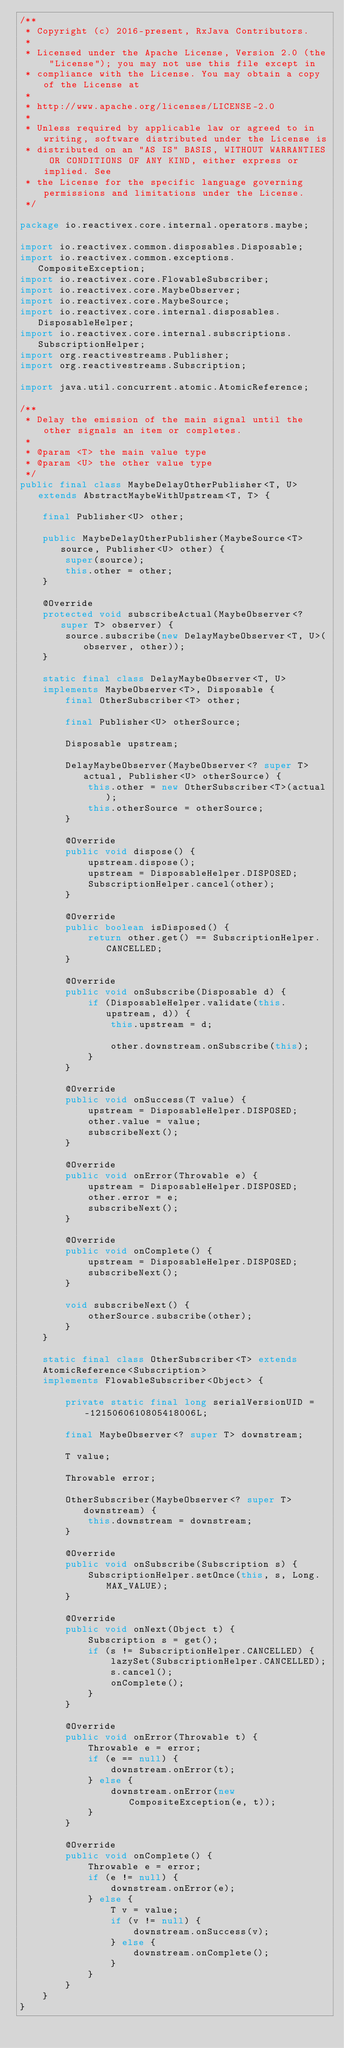Convert code to text. <code><loc_0><loc_0><loc_500><loc_500><_Java_>/**
 * Copyright (c) 2016-present, RxJava Contributors.
 *
 * Licensed under the Apache License, Version 2.0 (the "License"); you may not use this file except in
 * compliance with the License. You may obtain a copy of the License at
 *
 * http://www.apache.org/licenses/LICENSE-2.0
 *
 * Unless required by applicable law or agreed to in writing, software distributed under the License is
 * distributed on an "AS IS" BASIS, WITHOUT WARRANTIES OR CONDITIONS OF ANY KIND, either express or implied. See
 * the License for the specific language governing permissions and limitations under the License.
 */

package io.reactivex.core.internal.operators.maybe;

import io.reactivex.common.disposables.Disposable;
import io.reactivex.common.exceptions.CompositeException;
import io.reactivex.core.FlowableSubscriber;
import io.reactivex.core.MaybeObserver;
import io.reactivex.core.MaybeSource;
import io.reactivex.core.internal.disposables.DisposableHelper;
import io.reactivex.core.internal.subscriptions.SubscriptionHelper;
import org.reactivestreams.Publisher;
import org.reactivestreams.Subscription;

import java.util.concurrent.atomic.AtomicReference;

/**
 * Delay the emission of the main signal until the other signals an item or completes.
 * 
 * @param <T> the main value type
 * @param <U> the other value type
 */
public final class MaybeDelayOtherPublisher<T, U> extends AbstractMaybeWithUpstream<T, T> {

    final Publisher<U> other;

    public MaybeDelayOtherPublisher(MaybeSource<T> source, Publisher<U> other) {
        super(source);
        this.other = other;
    }

    @Override
    protected void subscribeActual(MaybeObserver<? super T> observer) {
        source.subscribe(new DelayMaybeObserver<T, U>(observer, other));
    }

    static final class DelayMaybeObserver<T, U>
    implements MaybeObserver<T>, Disposable {
        final OtherSubscriber<T> other;

        final Publisher<U> otherSource;

        Disposable upstream;

        DelayMaybeObserver(MaybeObserver<? super T> actual, Publisher<U> otherSource) {
            this.other = new OtherSubscriber<T>(actual);
            this.otherSource = otherSource;
        }

        @Override
        public void dispose() {
            upstream.dispose();
            upstream = DisposableHelper.DISPOSED;
            SubscriptionHelper.cancel(other);
        }

        @Override
        public boolean isDisposed() {
            return other.get() == SubscriptionHelper.CANCELLED;
        }

        @Override
        public void onSubscribe(Disposable d) {
            if (DisposableHelper.validate(this.upstream, d)) {
                this.upstream = d;

                other.downstream.onSubscribe(this);
            }
        }

        @Override
        public void onSuccess(T value) {
            upstream = DisposableHelper.DISPOSED;
            other.value = value;
            subscribeNext();
        }

        @Override
        public void onError(Throwable e) {
            upstream = DisposableHelper.DISPOSED;
            other.error = e;
            subscribeNext();
        }

        @Override
        public void onComplete() {
            upstream = DisposableHelper.DISPOSED;
            subscribeNext();
        }

        void subscribeNext() {
            otherSource.subscribe(other);
        }
    }

    static final class OtherSubscriber<T> extends
    AtomicReference<Subscription>
    implements FlowableSubscriber<Object> {

        private static final long serialVersionUID = -1215060610805418006L;

        final MaybeObserver<? super T> downstream;

        T value;

        Throwable error;

        OtherSubscriber(MaybeObserver<? super T> downstream) {
            this.downstream = downstream;
        }

        @Override
        public void onSubscribe(Subscription s) {
            SubscriptionHelper.setOnce(this, s, Long.MAX_VALUE);
        }

        @Override
        public void onNext(Object t) {
            Subscription s = get();
            if (s != SubscriptionHelper.CANCELLED) {
                lazySet(SubscriptionHelper.CANCELLED);
                s.cancel();
                onComplete();
            }
        }

        @Override
        public void onError(Throwable t) {
            Throwable e = error;
            if (e == null) {
                downstream.onError(t);
            } else {
                downstream.onError(new CompositeException(e, t));
            }
        }

        @Override
        public void onComplete() {
            Throwable e = error;
            if (e != null) {
                downstream.onError(e);
            } else {
                T v = value;
                if (v != null) {
                    downstream.onSuccess(v);
                } else {
                    downstream.onComplete();
                }
            }
        }
    }
}
</code> 